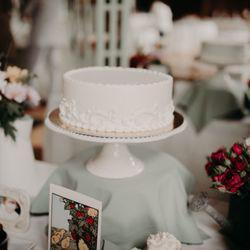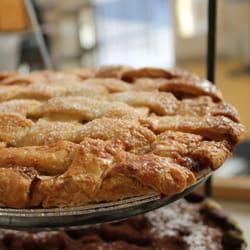The first image is the image on the left, the second image is the image on the right. Given the left and right images, does the statement "There are a multiple baked goods per image, exposed to open air." hold true? Answer yes or no. No. The first image is the image on the left, the second image is the image on the right. Examine the images to the left and right. Is the description "Pastries have yellow labels in one of the images." accurate? Answer yes or no. No. 